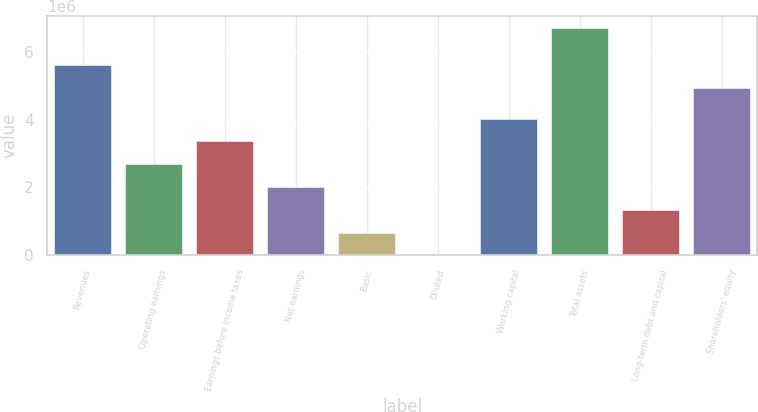Convert chart to OTSL. <chart><loc_0><loc_0><loc_500><loc_500><bar_chart><fcel>Revenues<fcel>Operating earnings<fcel>Earnings before income taxes<fcel>Net earnings<fcel>Basic<fcel>Diluted<fcel>Working capital<fcel>Total assets<fcel>Long-term debt and capital<fcel>Shareholders' equity<nl><fcel>5.59925e+06<fcel>2.68346e+06<fcel>3.35432e+06<fcel>2.01259e+06<fcel>670865<fcel>1.89<fcel>4.02518e+06<fcel>6.70864e+06<fcel>1.34173e+06<fcel>4.92839e+06<nl></chart> 